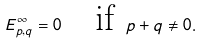<formula> <loc_0><loc_0><loc_500><loc_500>E ^ { \infty } _ { p , q } = 0 \quad \text {if } p + q \ne 0 .</formula> 